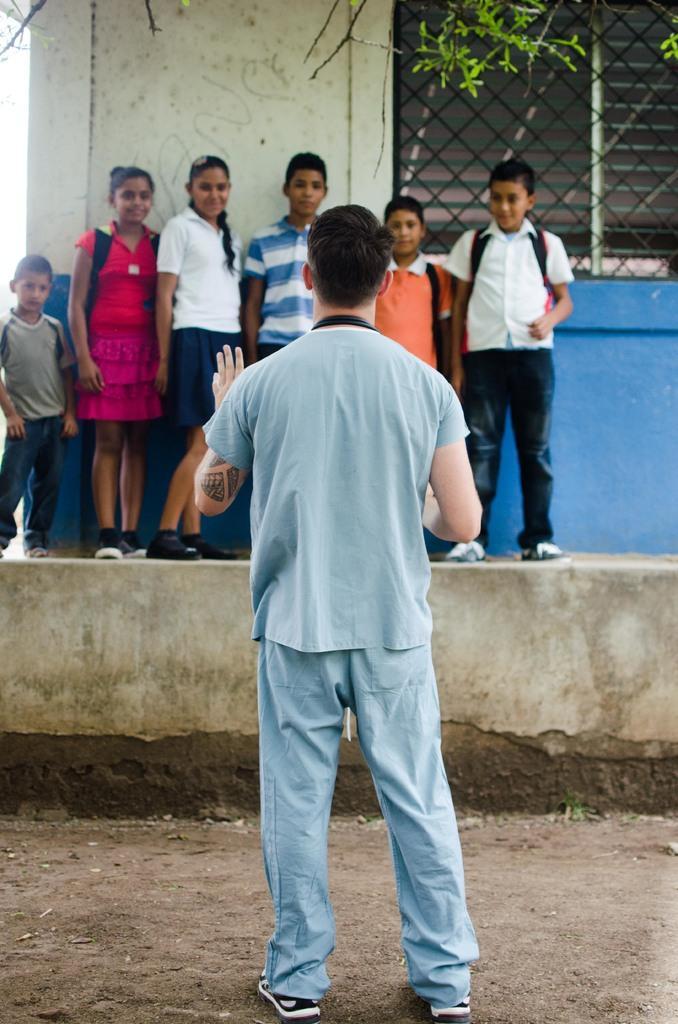How would you summarize this image in a sentence or two? In this image there is a person standing on the surface, in front of the person there are few children's standing in front of the building. At the top of the image we can see there are leaves of a tree. 